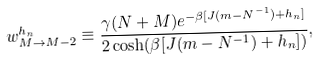<formula> <loc_0><loc_0><loc_500><loc_500>w ^ { h _ { n } } _ { M \to M - 2 } \equiv \frac { \gamma ( N + M ) e ^ { - \beta [ J ( m - N ^ { - 1 } ) + h _ { n } ] } } { 2 \cosh ( \beta [ J ( m - N ^ { - 1 } ) + h _ { n } ] ) } ,</formula> 